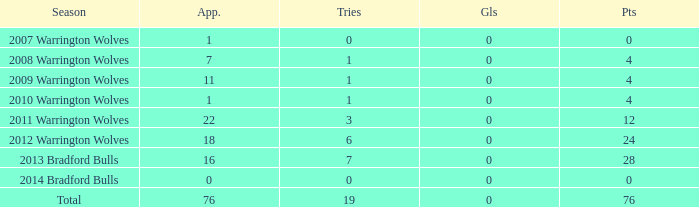What is the lowest appearance when goals is more than 0? None. 